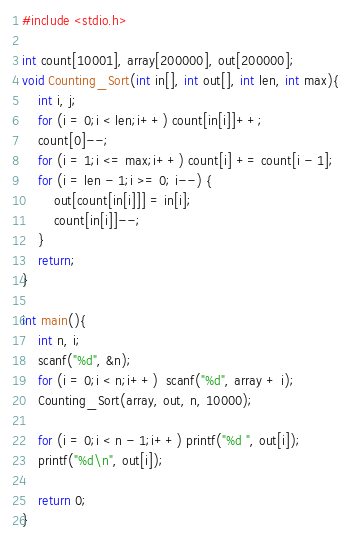Convert code to text. <code><loc_0><loc_0><loc_500><loc_500><_C_>#include <stdio.h>

int count[10001], array[200000], out[200000];
void Counting_Sort(int in[], int out[], int len, int max){
    int i, j;
    for (i = 0;i < len;i++) count[in[i]]++;
    count[0]--;
    for (i = 1;i <= max;i++) count[i] += count[i - 1];
    for (i = len - 1;i >= 0; i--) {
        out[count[in[i]]] = in[i];
        count[in[i]]--;
    }
    return;
}

int main(){
    int n, i;
    scanf("%d", &n);
    for (i = 0;i < n;i++)  scanf("%d", array + i);
    Counting_Sort(array, out, n, 10000);
    
    for (i = 0;i < n - 1;i++) printf("%d ", out[i]);
    printf("%d\n", out[i]);
    
    return 0;
}</code> 